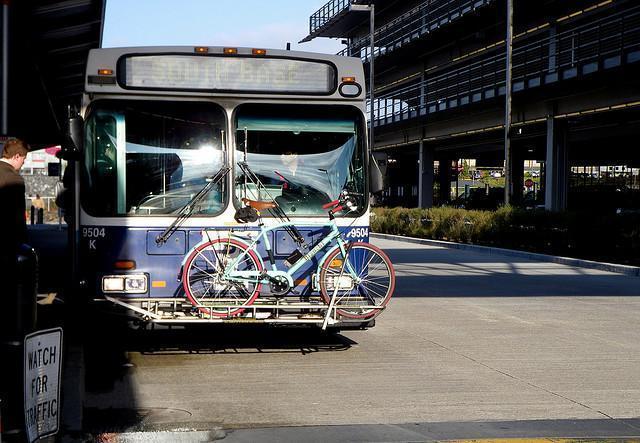Where is the rider of the bike?
Choose the right answer from the provided options to respond to the question.
Options: At home, in store, behind bus, in bus. In bus. 